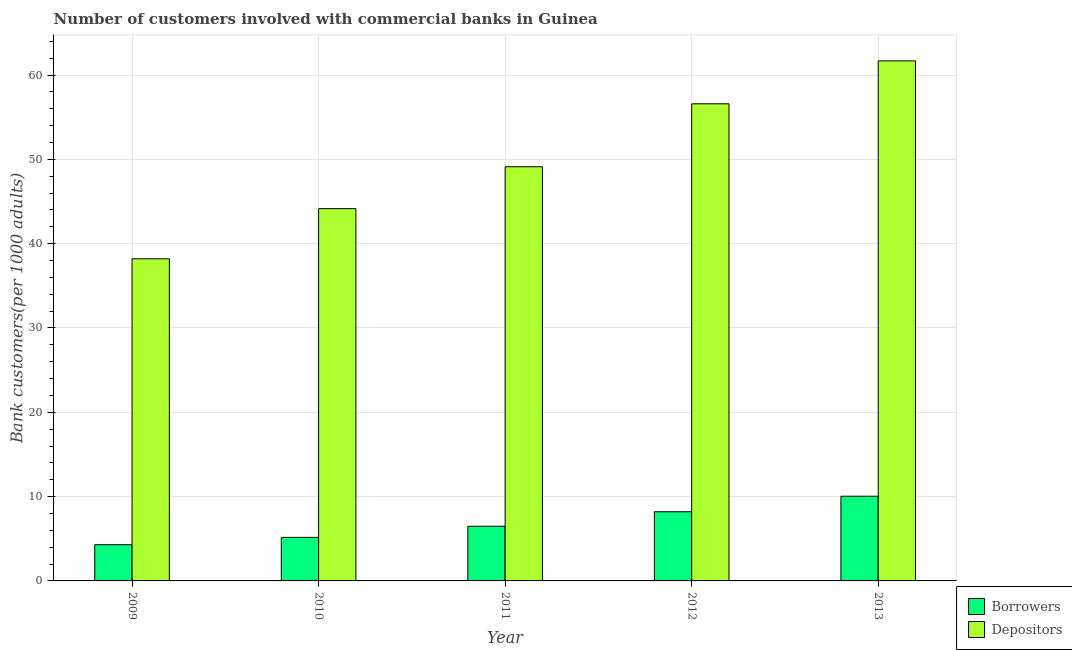How many different coloured bars are there?
Keep it short and to the point. 2. How many groups of bars are there?
Your answer should be compact. 5. Are the number of bars on each tick of the X-axis equal?
Provide a succinct answer. Yes. How many bars are there on the 4th tick from the right?
Your answer should be compact. 2. In how many cases, is the number of bars for a given year not equal to the number of legend labels?
Ensure brevity in your answer.  0. What is the number of borrowers in 2013?
Offer a very short reply. 10.05. Across all years, what is the maximum number of depositors?
Keep it short and to the point. 61.68. Across all years, what is the minimum number of borrowers?
Make the answer very short. 4.3. In which year was the number of depositors minimum?
Your answer should be compact. 2009. What is the total number of depositors in the graph?
Offer a very short reply. 249.76. What is the difference between the number of borrowers in 2009 and that in 2012?
Keep it short and to the point. -3.91. What is the difference between the number of borrowers in 2009 and the number of depositors in 2012?
Offer a very short reply. -3.91. What is the average number of borrowers per year?
Your response must be concise. 6.84. In the year 2011, what is the difference between the number of depositors and number of borrowers?
Keep it short and to the point. 0. What is the ratio of the number of depositors in 2009 to that in 2012?
Ensure brevity in your answer.  0.68. Is the difference between the number of depositors in 2012 and 2013 greater than the difference between the number of borrowers in 2012 and 2013?
Offer a very short reply. No. What is the difference between the highest and the second highest number of depositors?
Keep it short and to the point. 5.09. What is the difference between the highest and the lowest number of depositors?
Ensure brevity in your answer.  23.47. In how many years, is the number of borrowers greater than the average number of borrowers taken over all years?
Offer a terse response. 2. What does the 2nd bar from the left in 2010 represents?
Your answer should be very brief. Depositors. What does the 2nd bar from the right in 2012 represents?
Your answer should be compact. Borrowers. How many years are there in the graph?
Your response must be concise. 5. Where does the legend appear in the graph?
Provide a succinct answer. Bottom right. How many legend labels are there?
Your response must be concise. 2. What is the title of the graph?
Your response must be concise. Number of customers involved with commercial banks in Guinea. Does "Sanitation services" appear as one of the legend labels in the graph?
Your response must be concise. No. What is the label or title of the Y-axis?
Offer a very short reply. Bank customers(per 1000 adults). What is the Bank customers(per 1000 adults) of Borrowers in 2009?
Ensure brevity in your answer.  4.3. What is the Bank customers(per 1000 adults) in Depositors in 2009?
Your answer should be compact. 38.21. What is the Bank customers(per 1000 adults) of Borrowers in 2010?
Your answer should be very brief. 5.16. What is the Bank customers(per 1000 adults) in Depositors in 2010?
Offer a terse response. 44.16. What is the Bank customers(per 1000 adults) in Borrowers in 2011?
Provide a succinct answer. 6.48. What is the Bank customers(per 1000 adults) of Depositors in 2011?
Your answer should be compact. 49.12. What is the Bank customers(per 1000 adults) in Borrowers in 2012?
Offer a terse response. 8.2. What is the Bank customers(per 1000 adults) in Depositors in 2012?
Give a very brief answer. 56.59. What is the Bank customers(per 1000 adults) in Borrowers in 2013?
Your answer should be very brief. 10.05. What is the Bank customers(per 1000 adults) of Depositors in 2013?
Your response must be concise. 61.68. Across all years, what is the maximum Bank customers(per 1000 adults) of Borrowers?
Your answer should be very brief. 10.05. Across all years, what is the maximum Bank customers(per 1000 adults) of Depositors?
Offer a very short reply. 61.68. Across all years, what is the minimum Bank customers(per 1000 adults) of Borrowers?
Your response must be concise. 4.3. Across all years, what is the minimum Bank customers(per 1000 adults) in Depositors?
Your response must be concise. 38.21. What is the total Bank customers(per 1000 adults) of Borrowers in the graph?
Your answer should be very brief. 34.19. What is the total Bank customers(per 1000 adults) of Depositors in the graph?
Offer a very short reply. 249.76. What is the difference between the Bank customers(per 1000 adults) of Borrowers in 2009 and that in 2010?
Offer a terse response. -0.87. What is the difference between the Bank customers(per 1000 adults) of Depositors in 2009 and that in 2010?
Provide a succinct answer. -5.95. What is the difference between the Bank customers(per 1000 adults) in Borrowers in 2009 and that in 2011?
Your answer should be compact. -2.19. What is the difference between the Bank customers(per 1000 adults) in Depositors in 2009 and that in 2011?
Your answer should be very brief. -10.92. What is the difference between the Bank customers(per 1000 adults) in Borrowers in 2009 and that in 2012?
Ensure brevity in your answer.  -3.91. What is the difference between the Bank customers(per 1000 adults) of Depositors in 2009 and that in 2012?
Your answer should be very brief. -18.38. What is the difference between the Bank customers(per 1000 adults) of Borrowers in 2009 and that in 2013?
Your answer should be very brief. -5.75. What is the difference between the Bank customers(per 1000 adults) of Depositors in 2009 and that in 2013?
Offer a very short reply. -23.47. What is the difference between the Bank customers(per 1000 adults) in Borrowers in 2010 and that in 2011?
Provide a succinct answer. -1.32. What is the difference between the Bank customers(per 1000 adults) of Depositors in 2010 and that in 2011?
Your answer should be very brief. -4.97. What is the difference between the Bank customers(per 1000 adults) of Borrowers in 2010 and that in 2012?
Keep it short and to the point. -3.04. What is the difference between the Bank customers(per 1000 adults) in Depositors in 2010 and that in 2012?
Ensure brevity in your answer.  -12.44. What is the difference between the Bank customers(per 1000 adults) in Borrowers in 2010 and that in 2013?
Make the answer very short. -4.88. What is the difference between the Bank customers(per 1000 adults) in Depositors in 2010 and that in 2013?
Give a very brief answer. -17.53. What is the difference between the Bank customers(per 1000 adults) in Borrowers in 2011 and that in 2012?
Your response must be concise. -1.72. What is the difference between the Bank customers(per 1000 adults) in Depositors in 2011 and that in 2012?
Keep it short and to the point. -7.47. What is the difference between the Bank customers(per 1000 adults) of Borrowers in 2011 and that in 2013?
Give a very brief answer. -3.56. What is the difference between the Bank customers(per 1000 adults) of Depositors in 2011 and that in 2013?
Offer a very short reply. -12.56. What is the difference between the Bank customers(per 1000 adults) of Borrowers in 2012 and that in 2013?
Offer a terse response. -1.84. What is the difference between the Bank customers(per 1000 adults) of Depositors in 2012 and that in 2013?
Your answer should be compact. -5.09. What is the difference between the Bank customers(per 1000 adults) in Borrowers in 2009 and the Bank customers(per 1000 adults) in Depositors in 2010?
Your answer should be very brief. -39.86. What is the difference between the Bank customers(per 1000 adults) in Borrowers in 2009 and the Bank customers(per 1000 adults) in Depositors in 2011?
Provide a succinct answer. -44.83. What is the difference between the Bank customers(per 1000 adults) in Borrowers in 2009 and the Bank customers(per 1000 adults) in Depositors in 2012?
Provide a succinct answer. -52.29. What is the difference between the Bank customers(per 1000 adults) in Borrowers in 2009 and the Bank customers(per 1000 adults) in Depositors in 2013?
Your answer should be very brief. -57.39. What is the difference between the Bank customers(per 1000 adults) in Borrowers in 2010 and the Bank customers(per 1000 adults) in Depositors in 2011?
Your answer should be very brief. -43.96. What is the difference between the Bank customers(per 1000 adults) of Borrowers in 2010 and the Bank customers(per 1000 adults) of Depositors in 2012?
Your answer should be compact. -51.43. What is the difference between the Bank customers(per 1000 adults) in Borrowers in 2010 and the Bank customers(per 1000 adults) in Depositors in 2013?
Provide a succinct answer. -56.52. What is the difference between the Bank customers(per 1000 adults) of Borrowers in 2011 and the Bank customers(per 1000 adults) of Depositors in 2012?
Make the answer very short. -50.11. What is the difference between the Bank customers(per 1000 adults) in Borrowers in 2011 and the Bank customers(per 1000 adults) in Depositors in 2013?
Provide a succinct answer. -55.2. What is the difference between the Bank customers(per 1000 adults) of Borrowers in 2012 and the Bank customers(per 1000 adults) of Depositors in 2013?
Provide a succinct answer. -53.48. What is the average Bank customers(per 1000 adults) of Borrowers per year?
Offer a terse response. 6.84. What is the average Bank customers(per 1000 adults) in Depositors per year?
Keep it short and to the point. 49.95. In the year 2009, what is the difference between the Bank customers(per 1000 adults) of Borrowers and Bank customers(per 1000 adults) of Depositors?
Your answer should be compact. -33.91. In the year 2010, what is the difference between the Bank customers(per 1000 adults) in Borrowers and Bank customers(per 1000 adults) in Depositors?
Provide a succinct answer. -38.99. In the year 2011, what is the difference between the Bank customers(per 1000 adults) of Borrowers and Bank customers(per 1000 adults) of Depositors?
Provide a succinct answer. -42.64. In the year 2012, what is the difference between the Bank customers(per 1000 adults) in Borrowers and Bank customers(per 1000 adults) in Depositors?
Your response must be concise. -48.39. In the year 2013, what is the difference between the Bank customers(per 1000 adults) in Borrowers and Bank customers(per 1000 adults) in Depositors?
Ensure brevity in your answer.  -51.64. What is the ratio of the Bank customers(per 1000 adults) in Borrowers in 2009 to that in 2010?
Give a very brief answer. 0.83. What is the ratio of the Bank customers(per 1000 adults) of Depositors in 2009 to that in 2010?
Your response must be concise. 0.87. What is the ratio of the Bank customers(per 1000 adults) in Borrowers in 2009 to that in 2011?
Keep it short and to the point. 0.66. What is the ratio of the Bank customers(per 1000 adults) in Borrowers in 2009 to that in 2012?
Provide a succinct answer. 0.52. What is the ratio of the Bank customers(per 1000 adults) in Depositors in 2009 to that in 2012?
Your response must be concise. 0.68. What is the ratio of the Bank customers(per 1000 adults) in Borrowers in 2009 to that in 2013?
Your response must be concise. 0.43. What is the ratio of the Bank customers(per 1000 adults) of Depositors in 2009 to that in 2013?
Make the answer very short. 0.62. What is the ratio of the Bank customers(per 1000 adults) of Borrowers in 2010 to that in 2011?
Ensure brevity in your answer.  0.8. What is the ratio of the Bank customers(per 1000 adults) of Depositors in 2010 to that in 2011?
Your answer should be very brief. 0.9. What is the ratio of the Bank customers(per 1000 adults) of Borrowers in 2010 to that in 2012?
Make the answer very short. 0.63. What is the ratio of the Bank customers(per 1000 adults) of Depositors in 2010 to that in 2012?
Keep it short and to the point. 0.78. What is the ratio of the Bank customers(per 1000 adults) in Borrowers in 2010 to that in 2013?
Offer a terse response. 0.51. What is the ratio of the Bank customers(per 1000 adults) of Depositors in 2010 to that in 2013?
Offer a terse response. 0.72. What is the ratio of the Bank customers(per 1000 adults) of Borrowers in 2011 to that in 2012?
Your answer should be very brief. 0.79. What is the ratio of the Bank customers(per 1000 adults) of Depositors in 2011 to that in 2012?
Provide a short and direct response. 0.87. What is the ratio of the Bank customers(per 1000 adults) in Borrowers in 2011 to that in 2013?
Provide a succinct answer. 0.65. What is the ratio of the Bank customers(per 1000 adults) in Depositors in 2011 to that in 2013?
Your answer should be compact. 0.8. What is the ratio of the Bank customers(per 1000 adults) in Borrowers in 2012 to that in 2013?
Keep it short and to the point. 0.82. What is the ratio of the Bank customers(per 1000 adults) of Depositors in 2012 to that in 2013?
Provide a short and direct response. 0.92. What is the difference between the highest and the second highest Bank customers(per 1000 adults) of Borrowers?
Your answer should be very brief. 1.84. What is the difference between the highest and the second highest Bank customers(per 1000 adults) of Depositors?
Provide a succinct answer. 5.09. What is the difference between the highest and the lowest Bank customers(per 1000 adults) of Borrowers?
Provide a short and direct response. 5.75. What is the difference between the highest and the lowest Bank customers(per 1000 adults) in Depositors?
Your response must be concise. 23.47. 